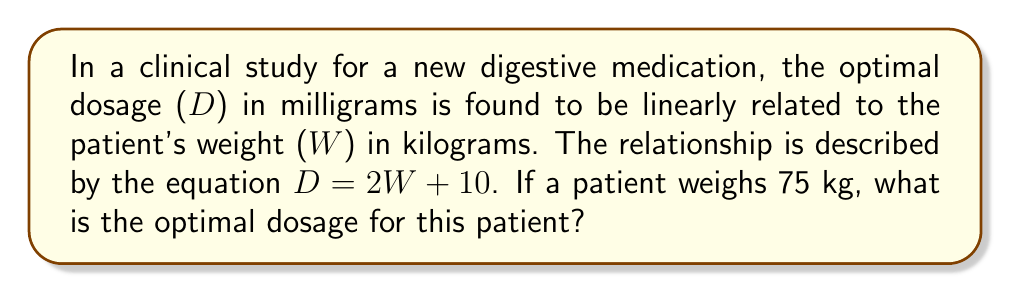Show me your answer to this math problem. To solve this problem, we'll follow these steps:

1) We're given the linear equation relating dosage (D) to weight (W):
   $D = 2W + 10$

2) We're also given the patient's weight:
   $W = 75$ kg

3) To find the optimal dosage, we simply need to substitute the given weight into the equation:
   $D = 2(75) + 10$

4) Let's solve this step-by-step:
   $D = 150 + 10$
   $D = 160$

5) Therefore, the optimal dosage for a patient weighing 75 kg is 160 mg.

This linear relationship allows us to quickly determine the appropriate dosage for patients of varying weights, which is crucial in clinical studies and personalized medicine approaches.
Answer: 160 mg 